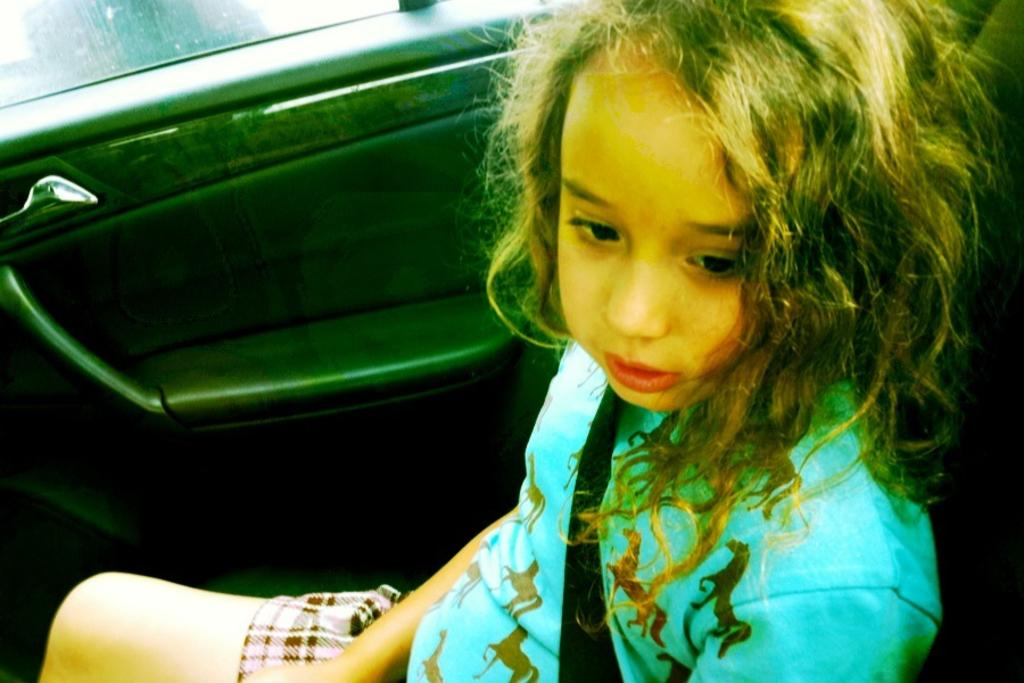Who is the main subject in the image? There is a girl in the image. What is the girl doing in the image? The girl is sitting in a car. What is the status of the car door in the image? The car door is closed. What type of veil is the girl wearing in the image? There is no veil present in the image; the girl is simply sitting in a car with the door closed. 